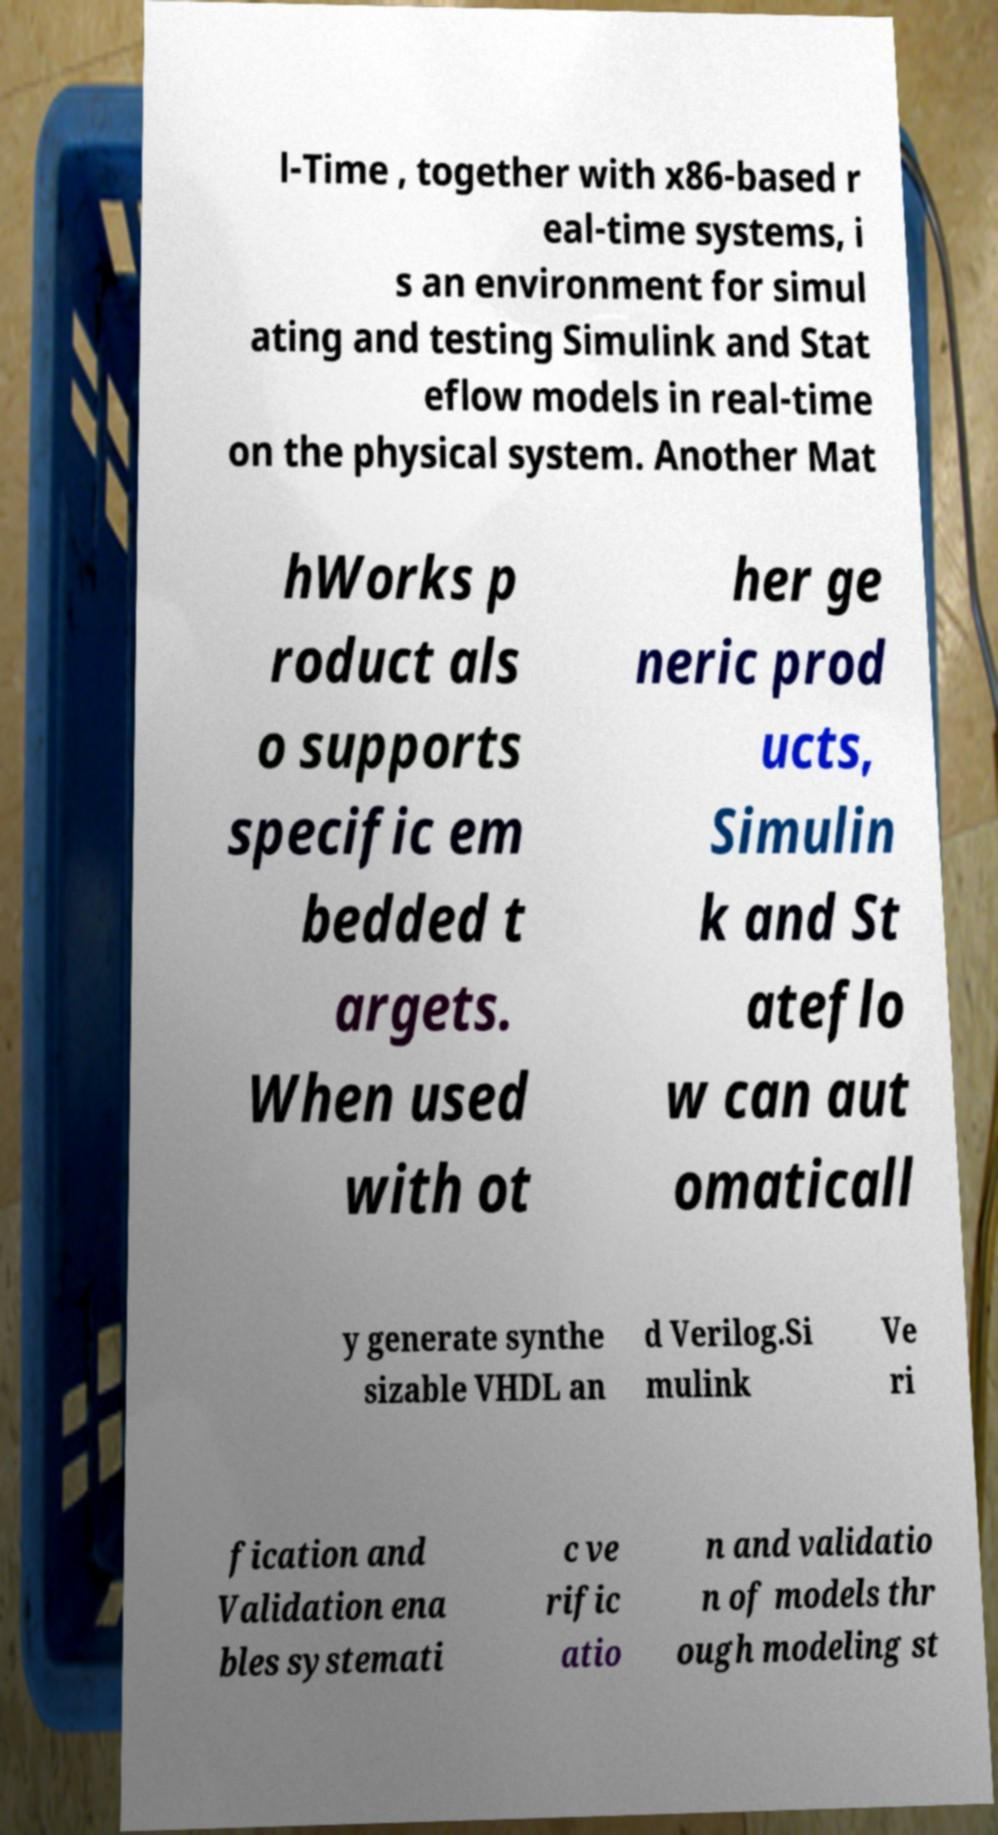For documentation purposes, I need the text within this image transcribed. Could you provide that? l-Time , together with x86-based r eal-time systems, i s an environment for simul ating and testing Simulink and Stat eflow models in real-time on the physical system. Another Mat hWorks p roduct als o supports specific em bedded t argets. When used with ot her ge neric prod ucts, Simulin k and St ateflo w can aut omaticall y generate synthe sizable VHDL an d Verilog.Si mulink Ve ri fication and Validation ena bles systemati c ve rific atio n and validatio n of models thr ough modeling st 